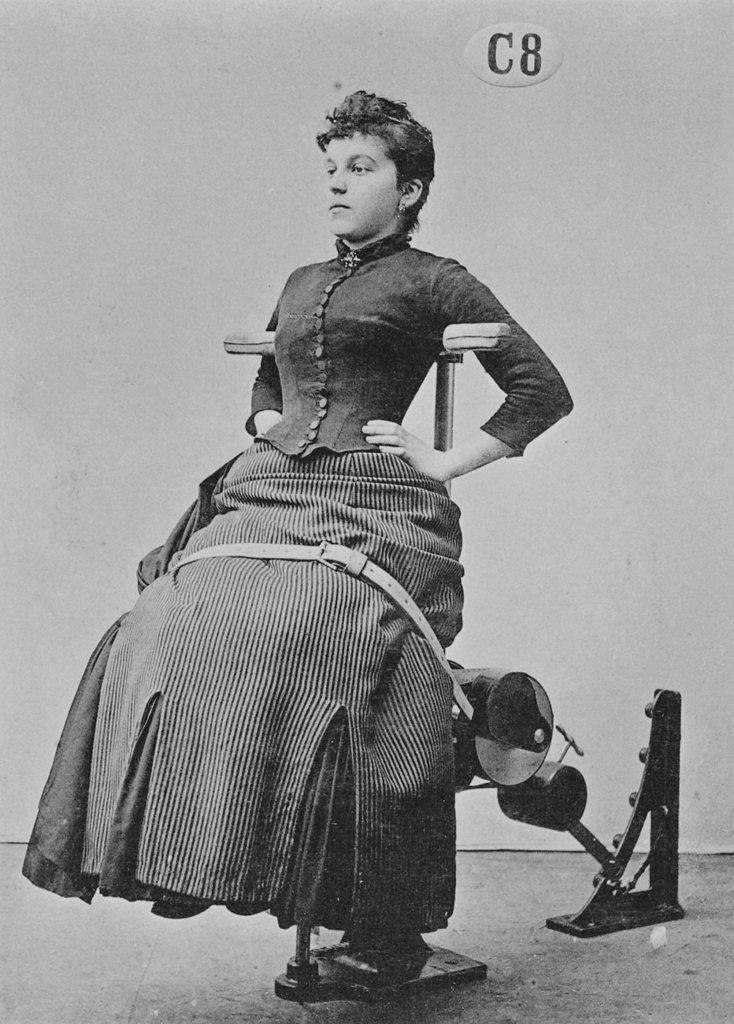How would you summarize this image in a sentence or two? This is a black and white picture. I can see a person sitting on the supporting chair, and in the background there is a kind of board attached to the wall. 